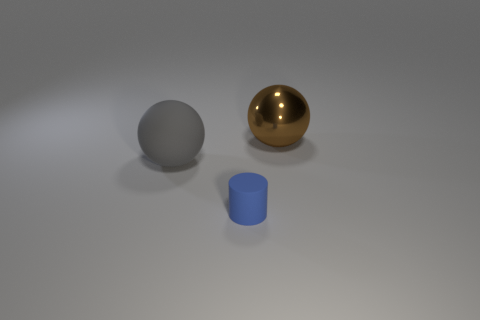Add 3 metal objects. How many objects exist? 6 Subtract all brown spheres. How many spheres are left? 1 Subtract all cylinders. How many objects are left? 2 Subtract all green balls. Subtract all green cubes. How many balls are left? 2 Subtract all green cubes. How many brown spheres are left? 1 Subtract all red shiny cylinders. Subtract all big things. How many objects are left? 1 Add 1 small blue matte objects. How many small blue matte objects are left? 2 Add 3 tiny blue objects. How many tiny blue objects exist? 4 Subtract 0 gray cylinders. How many objects are left? 3 